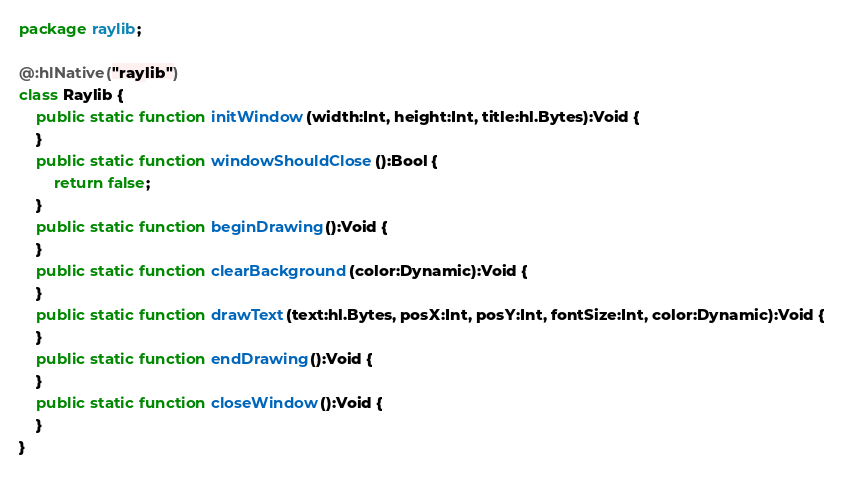Convert code to text. <code><loc_0><loc_0><loc_500><loc_500><_Haxe_>package raylib;

@:hlNative("raylib")
class Raylib {
	public static function initWindow(width:Int, height:Int, title:hl.Bytes):Void {
	}
	public static function windowShouldClose():Bool {
		return false;
	}
	public static function beginDrawing():Void {
	}
	public static function clearBackground(color:Dynamic):Void {
	}
	public static function drawText(text:hl.Bytes, posX:Int, posY:Int, fontSize:Int, color:Dynamic):Void {
	}
	public static function endDrawing():Void {
	}
	public static function closeWindow():Void {
	}
}
</code> 